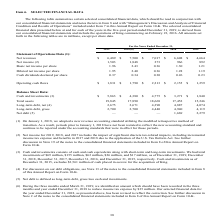According to Activision Blizzard's financial document, What did net income for 2019, 2018 and 2017 include? the impact of significant discrete tax-related impacts, including incremental income tax expense and benefits in 2017 and 2018 due to the application of the U.S. Tax Reform Act.. The document states: "(2) Net income for 2019, 2018, and 2017 includes the impact of significant discrete tax-related impacts, including incremental income tax expense and ..." Also, What was net revenue in 2019? According to the financial document, $6,489 (in millions). The relevant text states: "Statement of Operations Data (1): Net revenues $ 6,489 $ 7,500 $ 7,017 $ 6,608 $ 4,664..." Also, What was net income in 2019? According to the financial document, 1,503 (in millions). The relevant text states: "Net income (2) 1,503 1,848 273 966 892..." Also, can you calculate: What is the change in operating cash flows between 2018 and 2019? Based on the calculation: ($1,831-$1,790), the result is 41 (in millions). This is based on the information: "Operating cash flows $ 1,831 $ 1,790 $ 2,213 $ 2,155 $ 1,259 Operating cash flows $ 1,831 $ 1,790 $ 2,213 $ 2,155 $ 1,259..." The key data points involved are: 1,790, 1,831. Also, can you calculate: What is the change in total assets between 2015 and 2016? Based on the calculation: (17,452-15,246), the result is 2206 (in millions). This is based on the information: "Total assets 19,845 17,890 18,668 17,452 15,246 Total assets 19,845 17,890 18,668 17,452 15,246..." The key data points involved are: 15,246, 17,452. Also, can you calculate: What is the percentage change in Cash and Investments between 2016 and 2017? To answer this question, I need to perform calculations using the financial data. The calculation is: ($4,775-$3,271)/$3,271, which equals 45.98 (percentage). This is based on the information: "Data: Cash and investments (3) $ 5,863 $ 4,380 $ 4,775 $ 3,271 $ 1,840 ash and investments (3) $ 5,863 $ 4,380 $ 4,775 $ 3,271 $ 1,840..." The key data points involved are: 3,271, 4,775. 